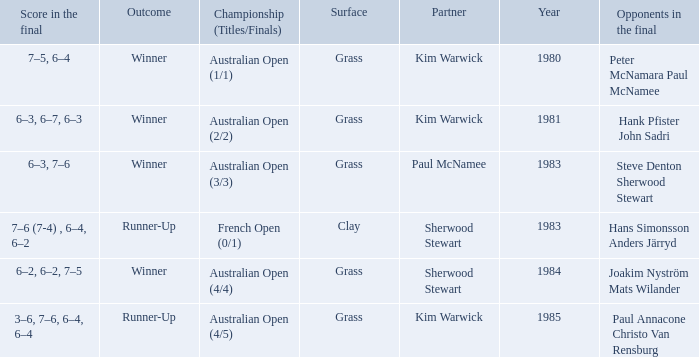How many different partners were played with during French Open (0/1)? 1.0. 